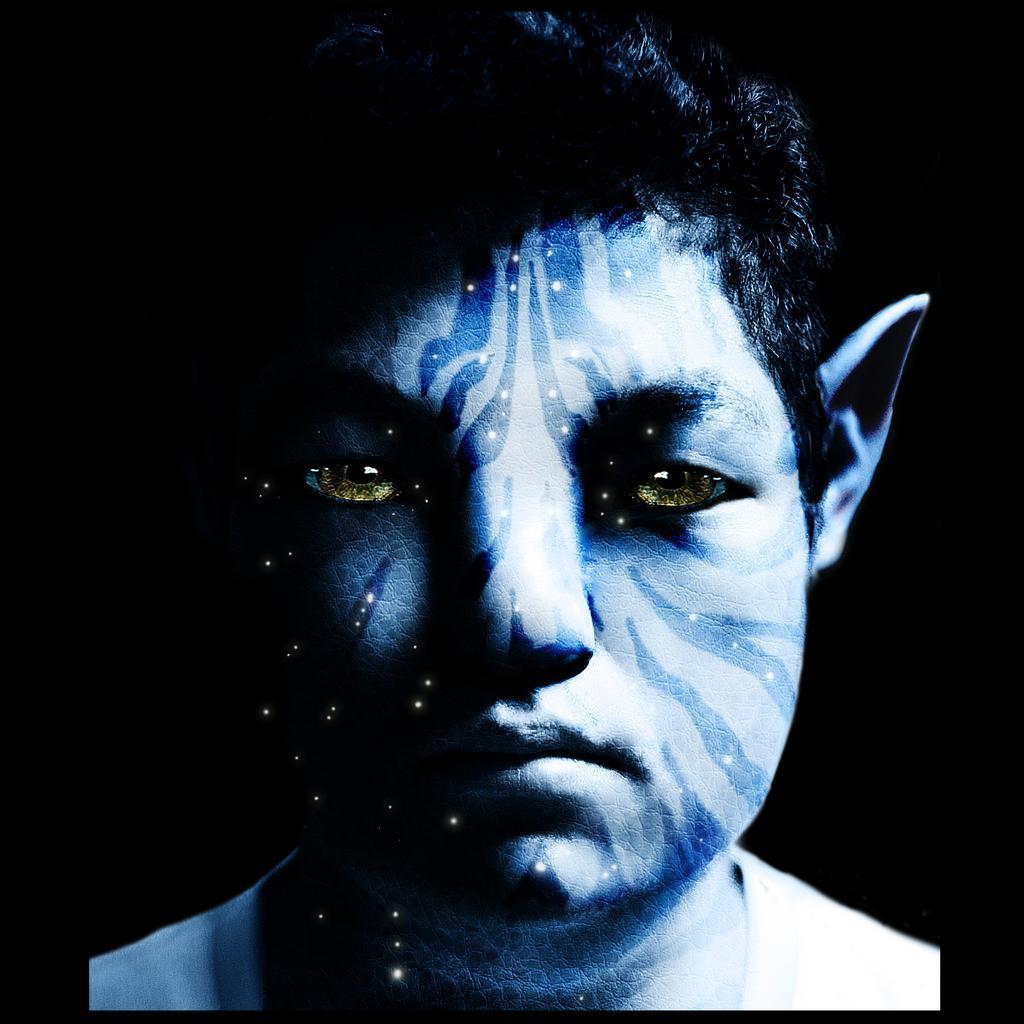Can you describe this image briefly? In this image, we can see an avatar on the dark background. 